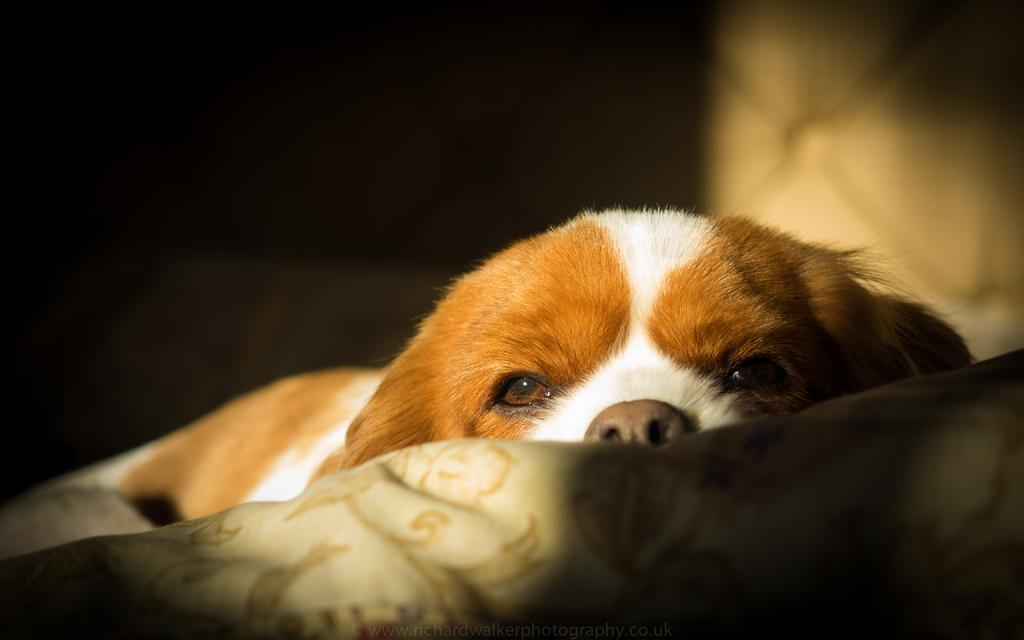What animal is present in the image? There is a dog in the image. What is the dog resting on? The dog is on a cloth. Can you describe the background of the image? The background of the image is blurred. What type of elbow can be seen in the image? There is no elbow present in the image; it features a dog resting on a cloth. Is there a horse visible in the image? No, there is no horse present in the image. 